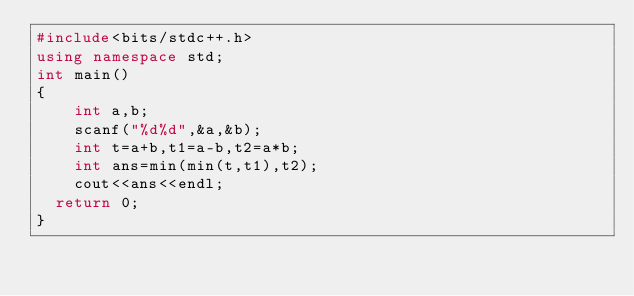<code> <loc_0><loc_0><loc_500><loc_500><_C++_>#include<bits/stdc++.h>
using namespace std;
int main()
{
  	int a,b;
  	scanf("%d%d",&a,&b);
  	int t=a+b,t1=a-b,t2=a*b;
  	int ans=min(min(t,t1),t2);
  	cout<<ans<<endl;
	return 0;
}</code> 